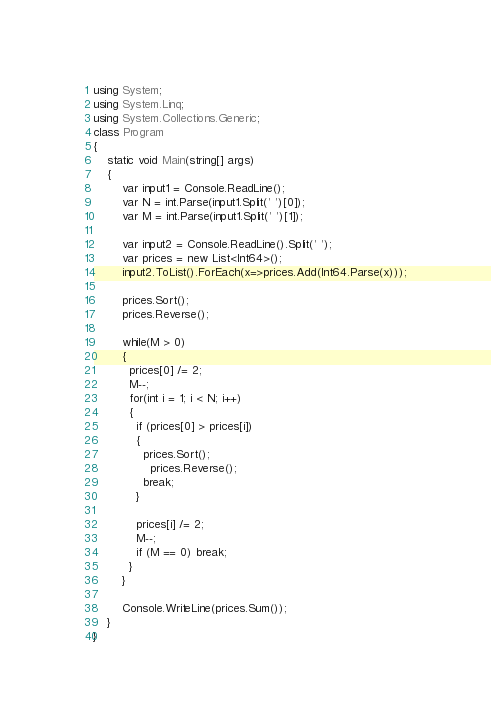<code> <loc_0><loc_0><loc_500><loc_500><_C#_>using System;
using System.Linq;
using System.Collections.Generic;
class Program
{
	static void Main(string[] args)
	{      
        var input1 = Console.ReadLine();
        var N = int.Parse(input1.Split(' ')[0]);
        var M = int.Parse(input1.Split(' ')[1]);
       
        var input2 = Console.ReadLine().Split(' ');
        var prices = new List<Int64>();
        input2.ToList().ForEach(x=>prices.Add(Int64.Parse(x)));
 
        prices.Sort();
        prices.Reverse();
 
      	while(M > 0)
        {
          prices[0] /= 2;
          M--;
          for(int i = 1; i < N; i++)
          {
            if (prices[0] > prices[i])
            {
              prices.Sort();
        		prices.Reverse();
              break;
            }

            prices[i] /= 2;
            M--;
            if (M == 0) break;
          }        
        }
      
     	Console.WriteLine(prices.Sum());
	}
}</code> 